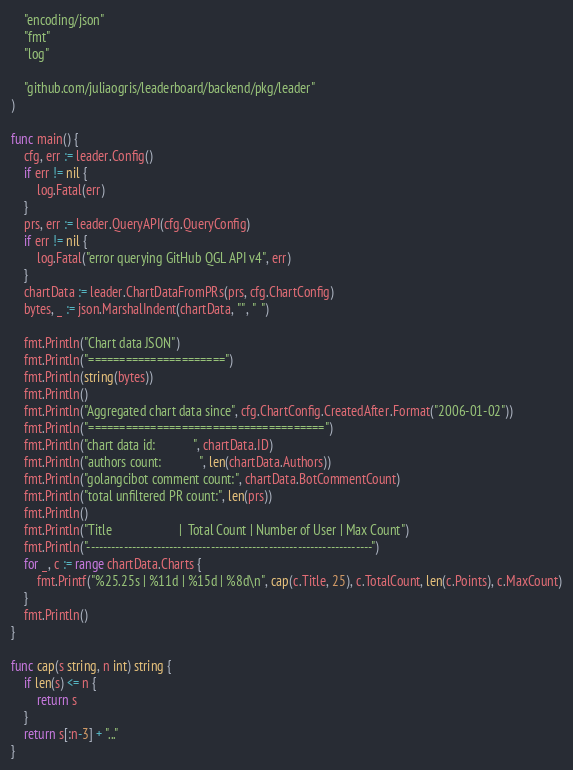Convert code to text. <code><loc_0><loc_0><loc_500><loc_500><_Go_>	"encoding/json"
	"fmt"
	"log"

	"github.com/juliaogris/leaderboard/backend/pkg/leader"
)

func main() {
	cfg, err := leader.Config()
	if err != nil {
		log.Fatal(err)
	}
	prs, err := leader.QueryAPI(cfg.QueryConfig)
	if err != nil {
		log.Fatal("error querying GitHub QGL API v4", err)
	}
	chartData := leader.ChartDataFromPRs(prs, cfg.ChartConfig)
	bytes, _ := json.MarshalIndent(chartData, "", "  ")

	fmt.Println("Chart data JSON")
	fmt.Println("======================")
	fmt.Println(string(bytes))
	fmt.Println()
	fmt.Println("Aggregated chart data since", cfg.ChartConfig.CreatedAfter.Format("2006-01-02"))
	fmt.Println("======================================")
	fmt.Println("chart data id:            ", chartData.ID)
	fmt.Println("authors count:            ", len(chartData.Authors))
	fmt.Println("golangcibot comment count:", chartData.BotCommentCount)
	fmt.Println("total unfiltered PR count:", len(prs))
	fmt.Println()
	fmt.Println("Title                     |  Total Count | Number of User | Max Count")
	fmt.Println("---------------------------------------------------------------------")
	for _, c := range chartData.Charts {
		fmt.Printf("%25.25s | %11d | %15d | %8d\n", cap(c.Title, 25), c.TotalCount, len(c.Points), c.MaxCount)
	}
	fmt.Println()
}

func cap(s string, n int) string {
	if len(s) <= n {
		return s
	}
	return s[:n-3] + "..."
}
</code> 